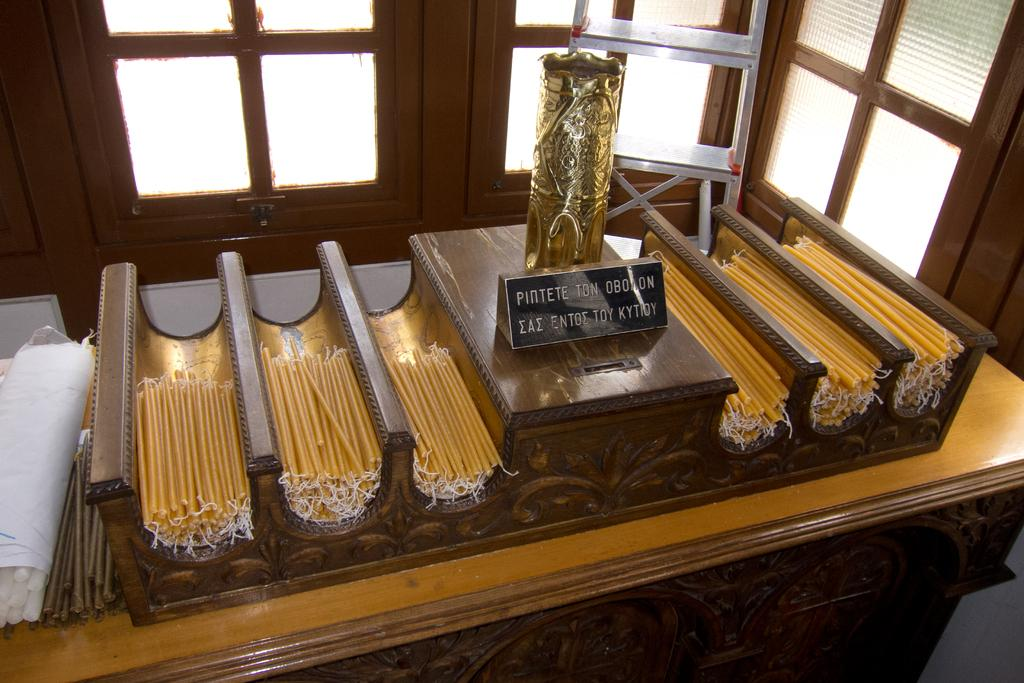What is the primary location of the objects in the image? The objects are placed on a table in the image. Can you describe the background of the image? There are windows visible behind the table in the image. What type of soup is being served on the table in the image? There is no soup present in the image; it only shows objects placed on a table with windows visible behind it. 